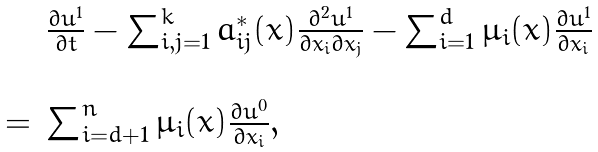<formula> <loc_0><loc_0><loc_500><loc_500>\begin{array} { l l } & \frac { \partial u ^ { 1 } } { \partial t } - \sum _ { i , j = 1 } ^ { k } a ^ { * } _ { i j } ( x ) \frac { \partial ^ { 2 } u ^ { 1 } } { \partial x _ { i } \partial x _ { j } } - \sum _ { i = 1 } ^ { d } \mu _ { i } ( x ) \frac { \partial u ^ { 1 } } { \partial x _ { i } } \\ \\ = & \sum _ { i = d + 1 } ^ { n } \mu _ { i } ( x ) \frac { \partial u ^ { 0 } } { \partial x _ { i } } , \end{array}</formula> 